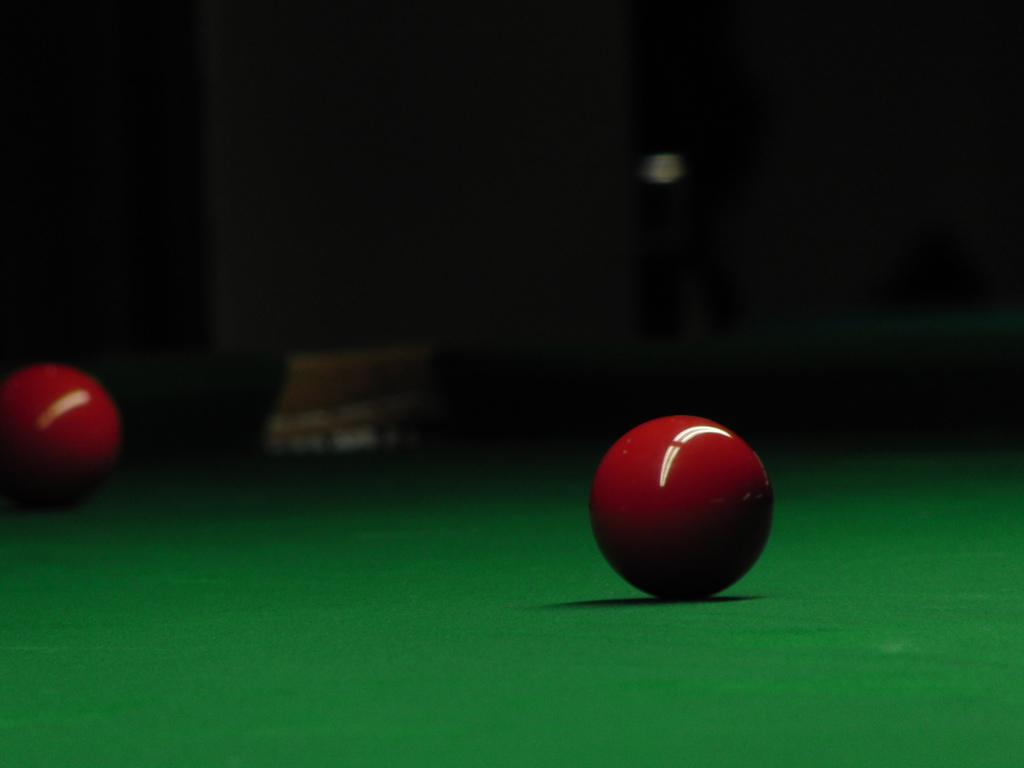What is the main object in the foreground of the image? There is a ball in the foreground of the image. Can you describe any other objects in the image? There is a green color object in the image, possibly a table, and a red color ball on the left side of the image. What is the color of the background in the image? The background of the image is dark. What type of yarn is being used to create the range of colors in the image? There is no yarn or range of colors present in the image; it features a ball in the foreground and a green color object, possibly a table. Can you see a button in the image? There is no button present in the image. 